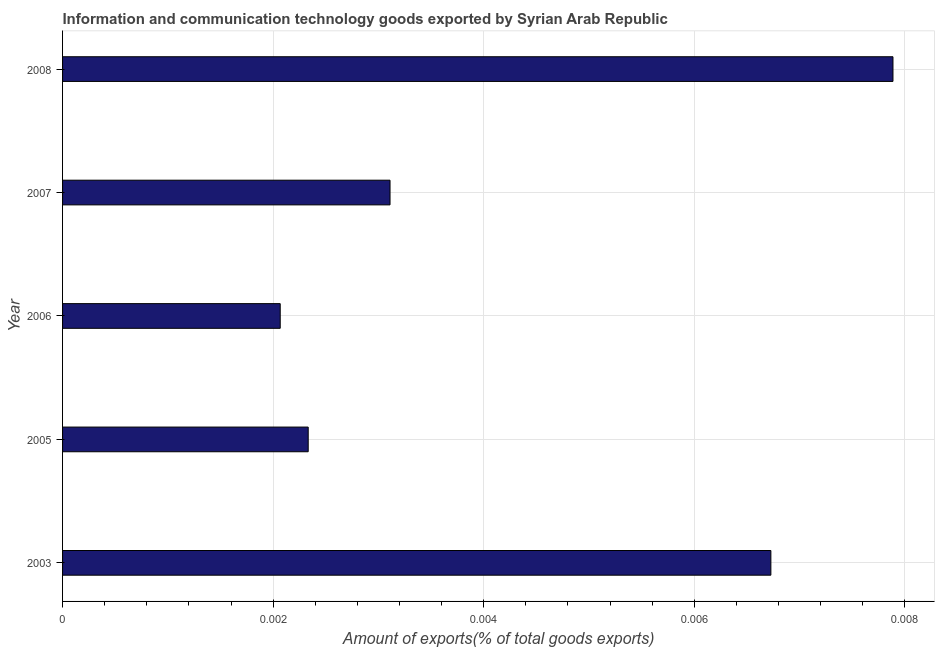Does the graph contain grids?
Give a very brief answer. Yes. What is the title of the graph?
Ensure brevity in your answer.  Information and communication technology goods exported by Syrian Arab Republic. What is the label or title of the X-axis?
Ensure brevity in your answer.  Amount of exports(% of total goods exports). What is the label or title of the Y-axis?
Your response must be concise. Year. What is the amount of ict goods exports in 2006?
Offer a very short reply. 0. Across all years, what is the maximum amount of ict goods exports?
Provide a succinct answer. 0.01. Across all years, what is the minimum amount of ict goods exports?
Provide a short and direct response. 0. In which year was the amount of ict goods exports minimum?
Your answer should be very brief. 2006. What is the sum of the amount of ict goods exports?
Give a very brief answer. 0.02. What is the difference between the amount of ict goods exports in 2007 and 2008?
Provide a succinct answer. -0.01. What is the average amount of ict goods exports per year?
Provide a succinct answer. 0. What is the median amount of ict goods exports?
Provide a succinct answer. 0. In how many years, is the amount of ict goods exports greater than 0.0012 %?
Offer a very short reply. 5. Do a majority of the years between 2003 and 2007 (inclusive) have amount of ict goods exports greater than 0.0016 %?
Your response must be concise. Yes. Is the amount of ict goods exports in 2005 less than that in 2006?
Make the answer very short. No. Is the difference between the amount of ict goods exports in 2005 and 2008 greater than the difference between any two years?
Ensure brevity in your answer.  No. Is the sum of the amount of ict goods exports in 2003 and 2008 greater than the maximum amount of ict goods exports across all years?
Your answer should be very brief. Yes. Are all the bars in the graph horizontal?
Provide a short and direct response. Yes. What is the difference between two consecutive major ticks on the X-axis?
Offer a terse response. 0. What is the Amount of exports(% of total goods exports) of 2003?
Ensure brevity in your answer.  0.01. What is the Amount of exports(% of total goods exports) in 2005?
Offer a terse response. 0. What is the Amount of exports(% of total goods exports) of 2006?
Give a very brief answer. 0. What is the Amount of exports(% of total goods exports) of 2007?
Give a very brief answer. 0. What is the Amount of exports(% of total goods exports) of 2008?
Give a very brief answer. 0.01. What is the difference between the Amount of exports(% of total goods exports) in 2003 and 2005?
Give a very brief answer. 0. What is the difference between the Amount of exports(% of total goods exports) in 2003 and 2006?
Give a very brief answer. 0. What is the difference between the Amount of exports(% of total goods exports) in 2003 and 2007?
Your answer should be compact. 0. What is the difference between the Amount of exports(% of total goods exports) in 2003 and 2008?
Keep it short and to the point. -0. What is the difference between the Amount of exports(% of total goods exports) in 2005 and 2006?
Keep it short and to the point. 0. What is the difference between the Amount of exports(% of total goods exports) in 2005 and 2007?
Keep it short and to the point. -0. What is the difference between the Amount of exports(% of total goods exports) in 2005 and 2008?
Your response must be concise. -0.01. What is the difference between the Amount of exports(% of total goods exports) in 2006 and 2007?
Your response must be concise. -0. What is the difference between the Amount of exports(% of total goods exports) in 2006 and 2008?
Make the answer very short. -0.01. What is the difference between the Amount of exports(% of total goods exports) in 2007 and 2008?
Provide a succinct answer. -0. What is the ratio of the Amount of exports(% of total goods exports) in 2003 to that in 2005?
Ensure brevity in your answer.  2.88. What is the ratio of the Amount of exports(% of total goods exports) in 2003 to that in 2006?
Your answer should be compact. 3.25. What is the ratio of the Amount of exports(% of total goods exports) in 2003 to that in 2007?
Keep it short and to the point. 2.16. What is the ratio of the Amount of exports(% of total goods exports) in 2003 to that in 2008?
Your answer should be compact. 0.85. What is the ratio of the Amount of exports(% of total goods exports) in 2005 to that in 2006?
Keep it short and to the point. 1.13. What is the ratio of the Amount of exports(% of total goods exports) in 2005 to that in 2007?
Your answer should be compact. 0.75. What is the ratio of the Amount of exports(% of total goods exports) in 2005 to that in 2008?
Provide a short and direct response. 0.3. What is the ratio of the Amount of exports(% of total goods exports) in 2006 to that in 2007?
Keep it short and to the point. 0.67. What is the ratio of the Amount of exports(% of total goods exports) in 2006 to that in 2008?
Your answer should be compact. 0.26. What is the ratio of the Amount of exports(% of total goods exports) in 2007 to that in 2008?
Your answer should be very brief. 0.39. 